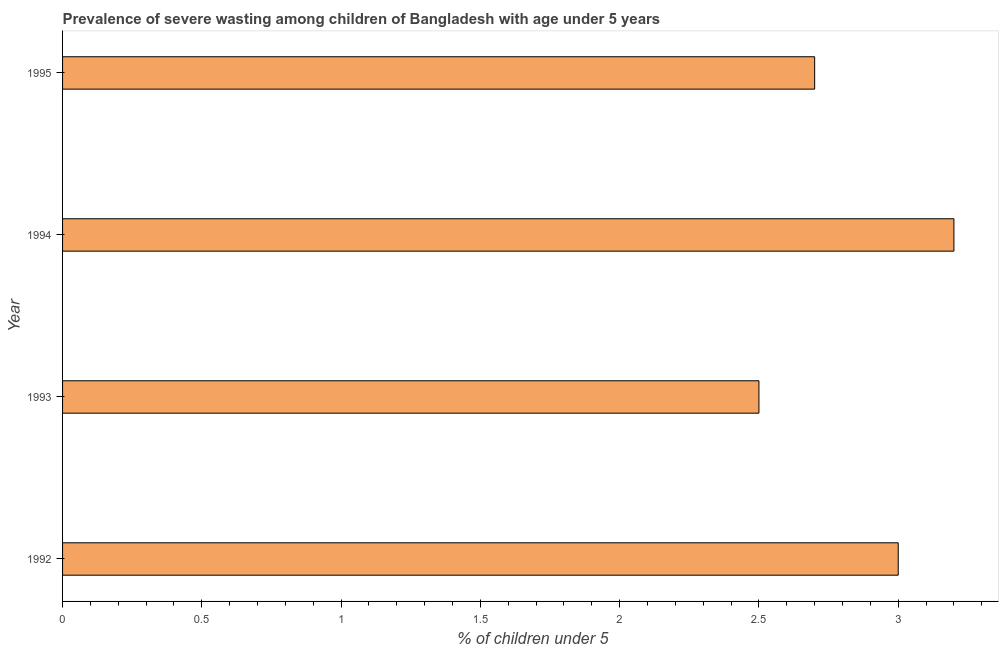Does the graph contain any zero values?
Ensure brevity in your answer.  No. Does the graph contain grids?
Ensure brevity in your answer.  No. What is the title of the graph?
Your answer should be very brief. Prevalence of severe wasting among children of Bangladesh with age under 5 years. What is the label or title of the X-axis?
Make the answer very short.  % of children under 5. What is the label or title of the Y-axis?
Make the answer very short. Year. What is the prevalence of severe wasting in 1994?
Your answer should be very brief. 3.2. Across all years, what is the maximum prevalence of severe wasting?
Provide a short and direct response. 3.2. What is the sum of the prevalence of severe wasting?
Offer a terse response. 11.4. What is the average prevalence of severe wasting per year?
Offer a very short reply. 2.85. What is the median prevalence of severe wasting?
Keep it short and to the point. 2.85. In how many years, is the prevalence of severe wasting greater than 2.3 %?
Provide a short and direct response. 4. Do a majority of the years between 1992 and 1994 (inclusive) have prevalence of severe wasting greater than 2 %?
Offer a terse response. Yes. What is the ratio of the prevalence of severe wasting in 1993 to that in 1995?
Your answer should be compact. 0.93. Is the prevalence of severe wasting in 1993 less than that in 1994?
Keep it short and to the point. Yes. Is the difference between the prevalence of severe wasting in 1992 and 1995 greater than the difference between any two years?
Your response must be concise. No. In how many years, is the prevalence of severe wasting greater than the average prevalence of severe wasting taken over all years?
Offer a very short reply. 2. How many bars are there?
Make the answer very short. 4. Are all the bars in the graph horizontal?
Provide a short and direct response. Yes. How many years are there in the graph?
Give a very brief answer. 4. What is the difference between two consecutive major ticks on the X-axis?
Give a very brief answer. 0.5. Are the values on the major ticks of X-axis written in scientific E-notation?
Provide a short and direct response. No. What is the  % of children under 5 in 1994?
Give a very brief answer. 3.2. What is the  % of children under 5 of 1995?
Offer a terse response. 2.7. What is the difference between the  % of children under 5 in 1992 and 1995?
Ensure brevity in your answer.  0.3. What is the difference between the  % of children under 5 in 1993 and 1994?
Your response must be concise. -0.7. What is the difference between the  % of children under 5 in 1993 and 1995?
Provide a short and direct response. -0.2. What is the difference between the  % of children under 5 in 1994 and 1995?
Make the answer very short. 0.5. What is the ratio of the  % of children under 5 in 1992 to that in 1994?
Give a very brief answer. 0.94. What is the ratio of the  % of children under 5 in 1992 to that in 1995?
Your answer should be very brief. 1.11. What is the ratio of the  % of children under 5 in 1993 to that in 1994?
Your answer should be very brief. 0.78. What is the ratio of the  % of children under 5 in 1993 to that in 1995?
Ensure brevity in your answer.  0.93. What is the ratio of the  % of children under 5 in 1994 to that in 1995?
Keep it short and to the point. 1.19. 